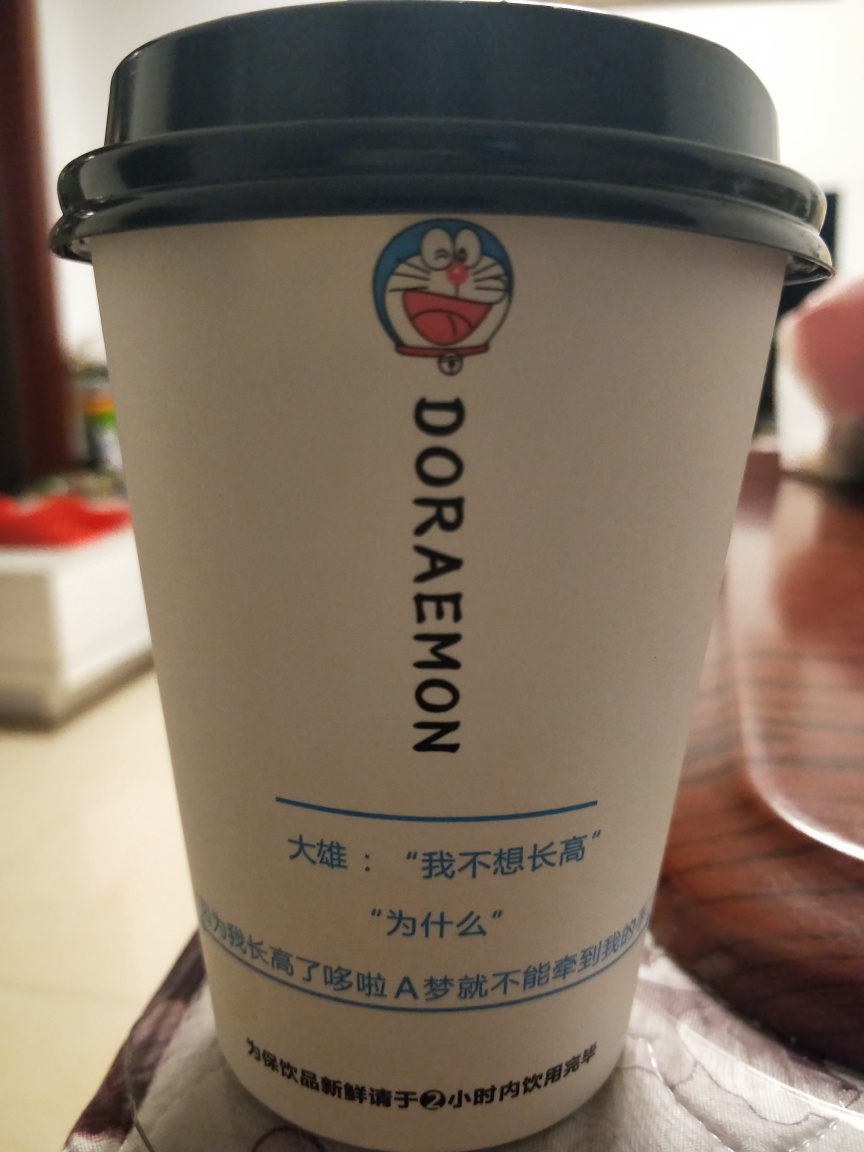How well are the texture details on the cup preserved in this image?
A. decent
B. absent
C. flawless
Answer with the option's letter from the given choices directly.
 A. 